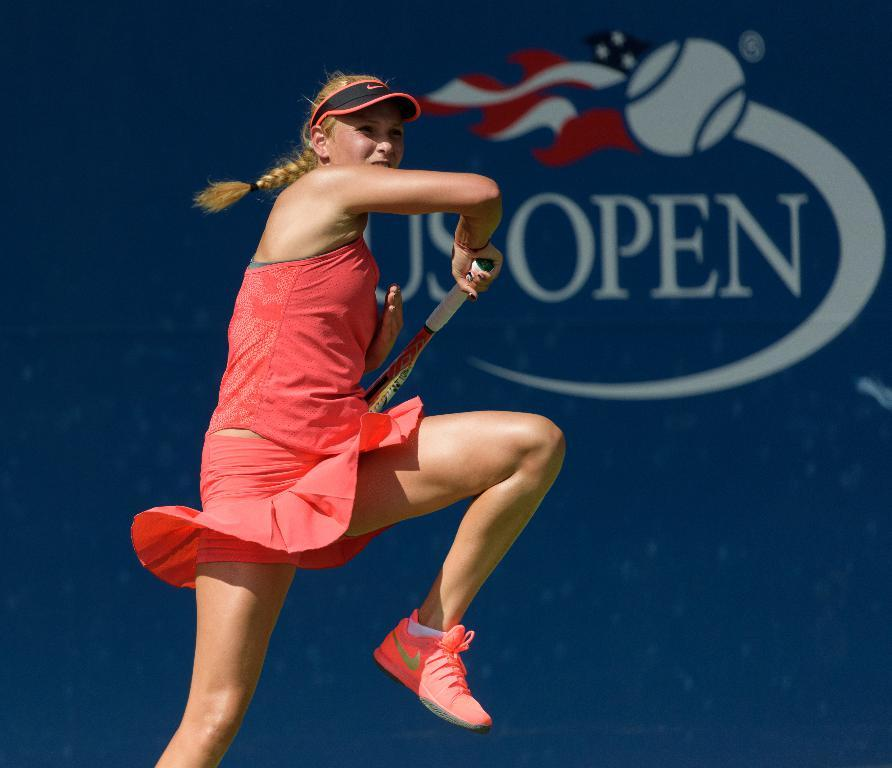What is the woman in the image doing? The woman is playing tennis in the image. What is the woman wearing while playing tennis? The woman is wearing a red dress and red shoes. What type of straw can be seen in the woman's hair in the image? There is no straw present in the woman's hair in the image. 